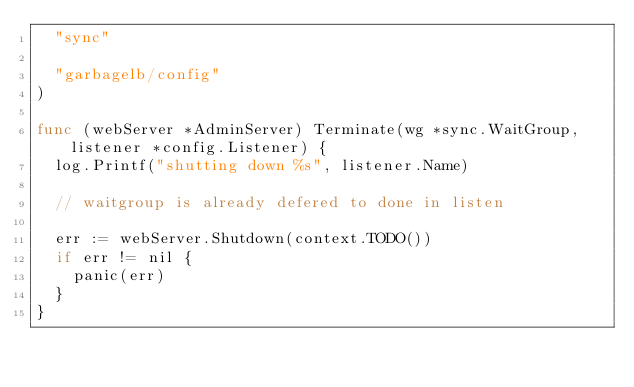Convert code to text. <code><loc_0><loc_0><loc_500><loc_500><_Go_>	"sync"

	"garbagelb/config"
)

func (webServer *AdminServer) Terminate(wg *sync.WaitGroup, listener *config.Listener) {
	log.Printf("shutting down %s", listener.Name)

	// waitgroup is already defered to done in listen

	err := webServer.Shutdown(context.TODO())
	if err != nil {
		panic(err)
	}
}
</code> 